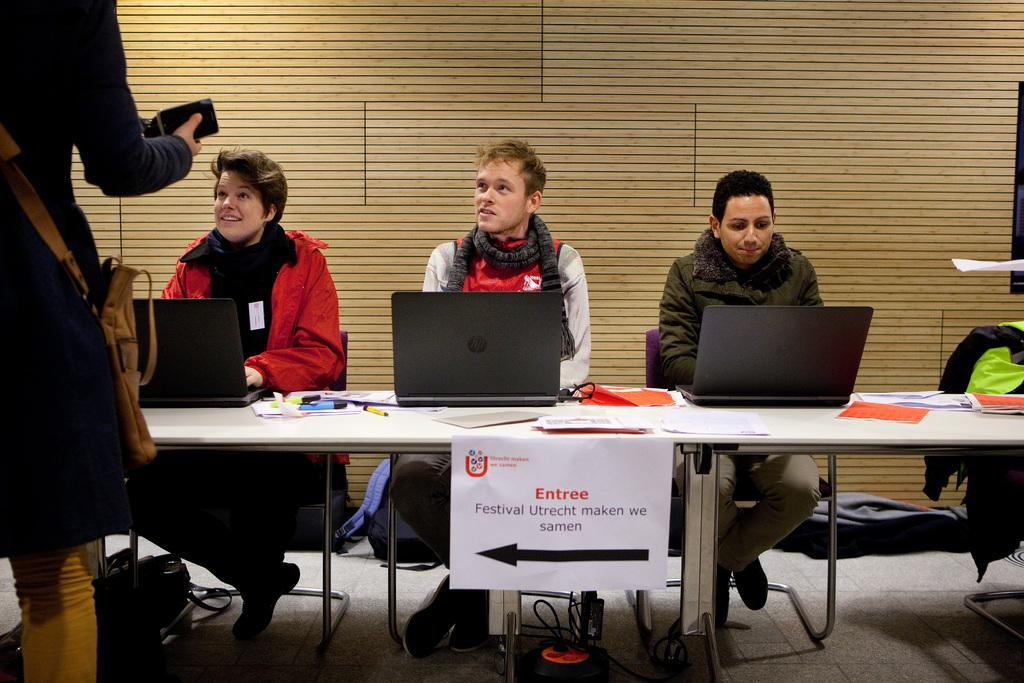How many people are sitting in the image? There are three people sitting on chairs in the image. What is on the table in the image? Papers, a marker, and a laptop are on the table in the image. What is the standing person wearing? The standing person is wearing a bag. What type of trees can be seen in the image? There are no trees present in the image. How does the behavior of the people in the image reflect their mood? The provided facts do not give any information about the people's mood or behavior, so we cannot answer this question. 